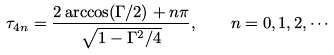<formula> <loc_0><loc_0><loc_500><loc_500>\tau _ { 4 n } = \frac { 2 \arccos ( \Gamma / 2 ) + n \pi } { \sqrt { 1 - \Gamma ^ { 2 } / 4 } } , \quad n = 0 , 1 , 2 , \cdots</formula> 